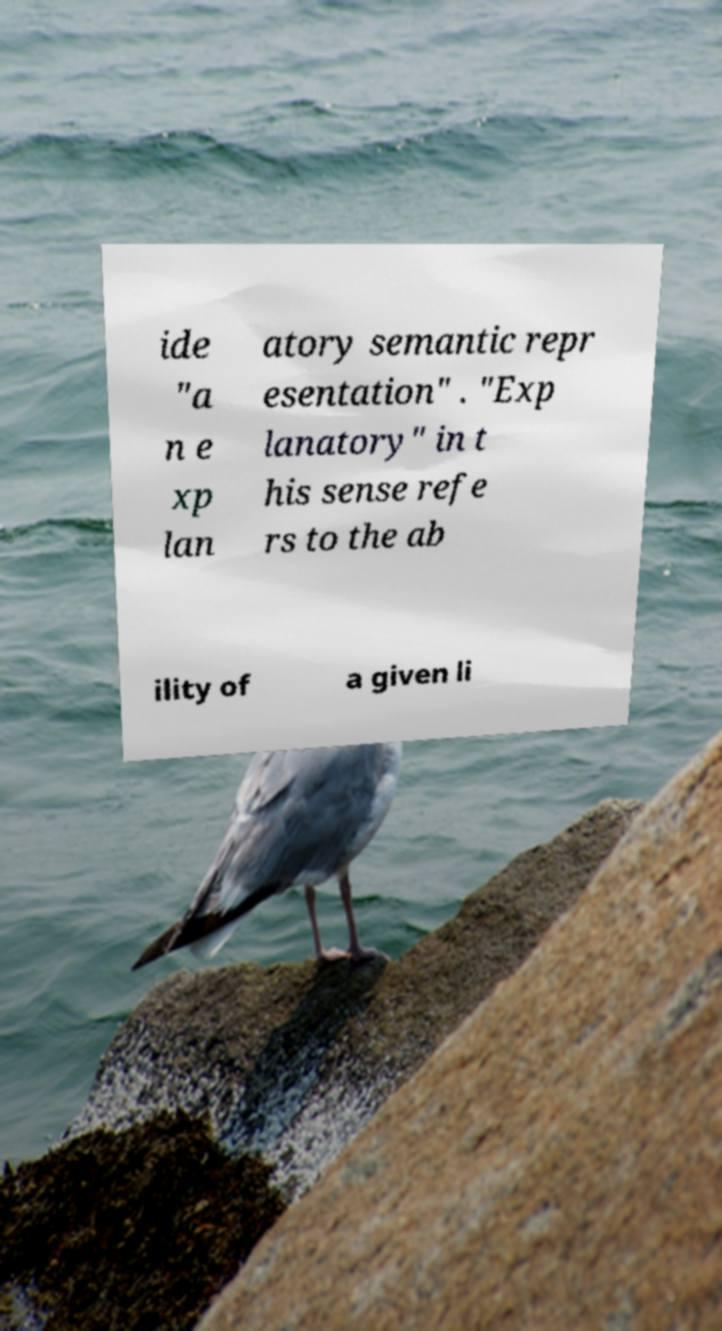Please read and relay the text visible in this image. What does it say? ide "a n e xp lan atory semantic repr esentation" . "Exp lanatory" in t his sense refe rs to the ab ility of a given li 